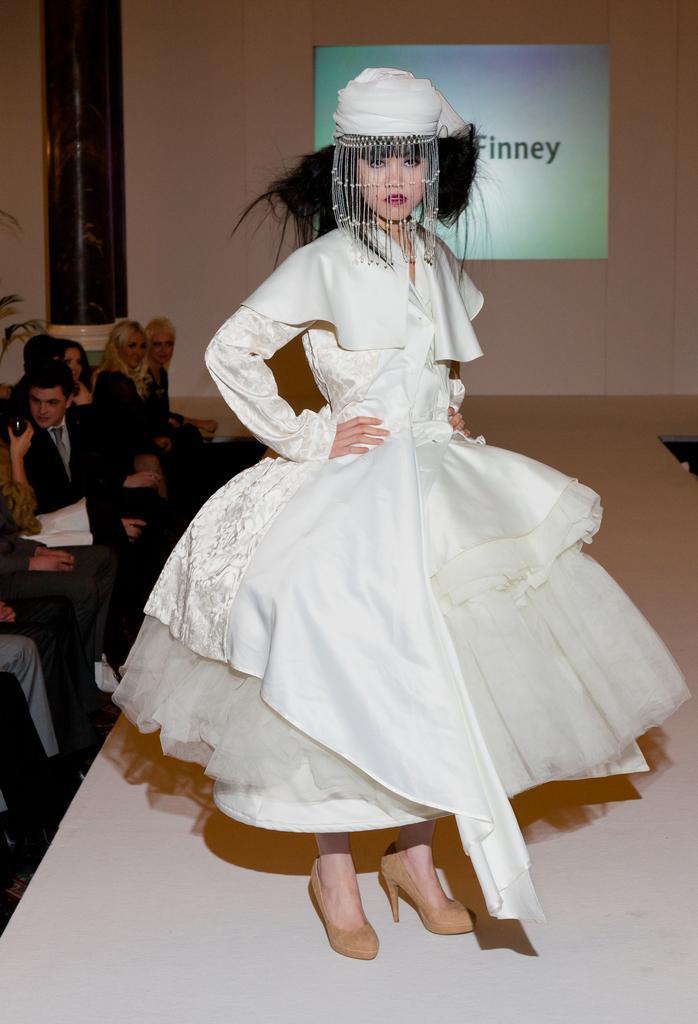Describe this image in one or two sentences. This is the woman standing. She wore a white frock and heels. There are group of people sitting on the chairs. This looks like a pillar. I think this is the board attached to the wall. 